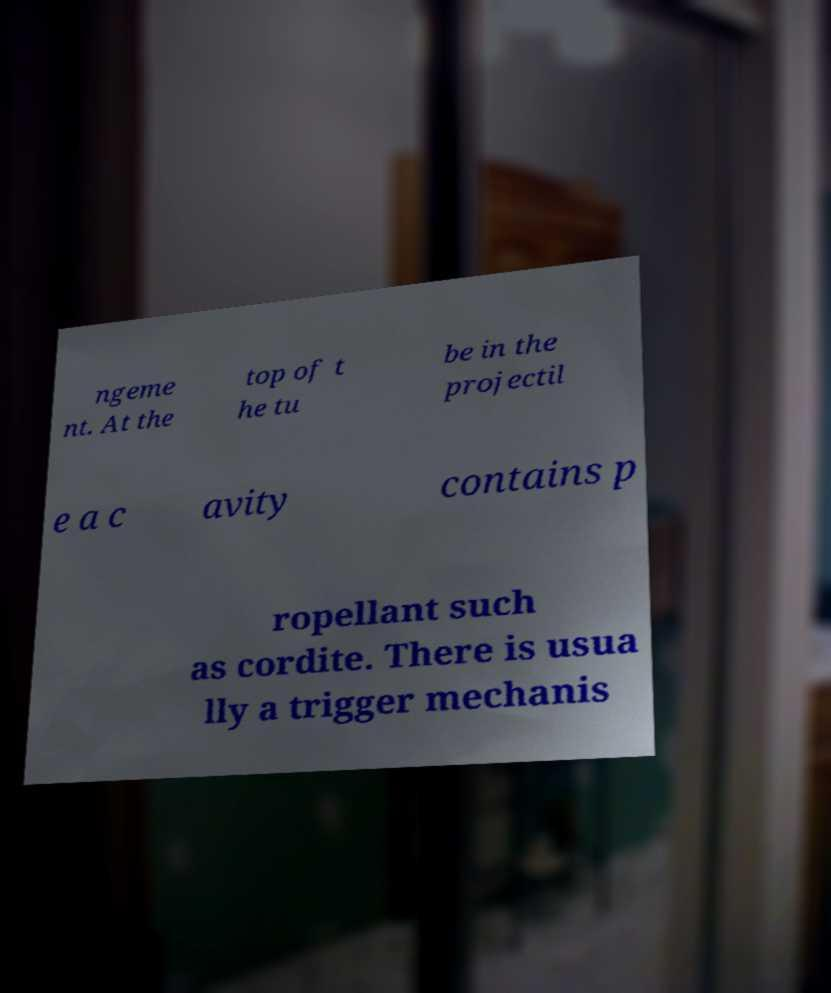There's text embedded in this image that I need extracted. Can you transcribe it verbatim? ngeme nt. At the top of t he tu be in the projectil e a c avity contains p ropellant such as cordite. There is usua lly a trigger mechanis 